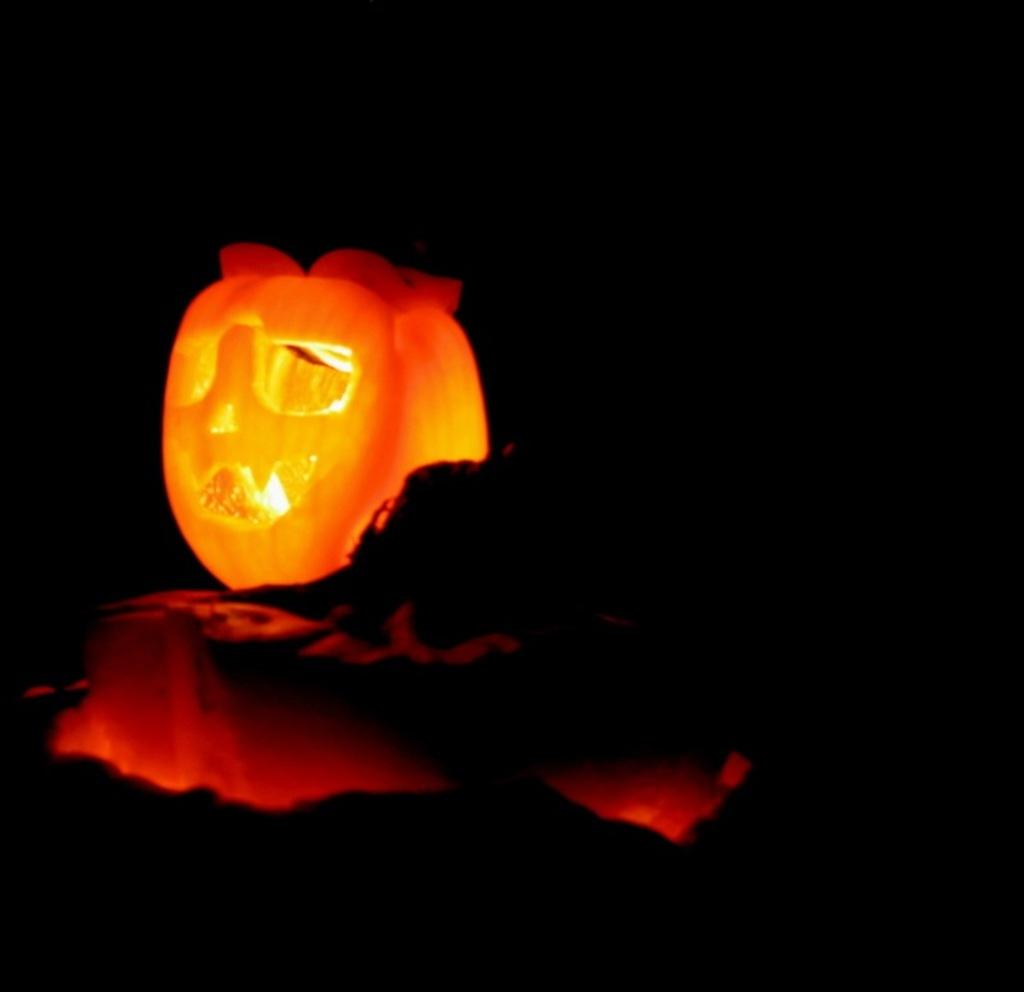What type of object is the main focus of the image? There is a Halloween pumpkin in the image. What type of creature is hiding inside the pumpkin in the image? There is no creature present in the image; it only features a Halloween pumpkin. What sound does the pumpkin make when it is rubbed in the image? The pumpkin does not make any sound in the image, as it is a still image and not a video. 